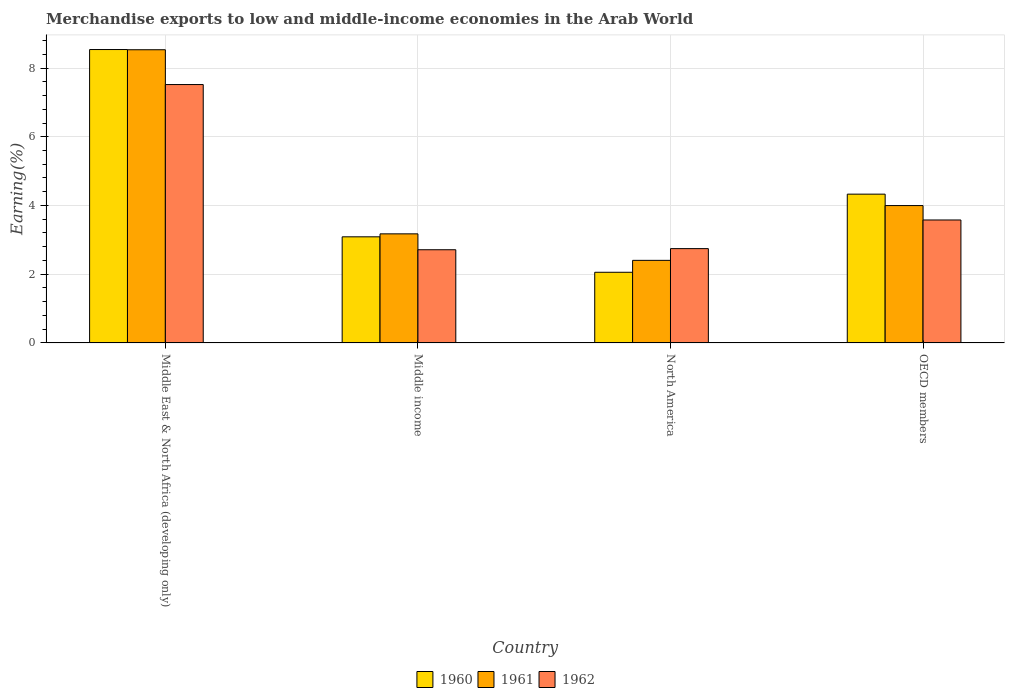How many groups of bars are there?
Provide a succinct answer. 4. Are the number of bars per tick equal to the number of legend labels?
Give a very brief answer. Yes. Are the number of bars on each tick of the X-axis equal?
Offer a very short reply. Yes. How many bars are there on the 1st tick from the left?
Ensure brevity in your answer.  3. In how many cases, is the number of bars for a given country not equal to the number of legend labels?
Ensure brevity in your answer.  0. What is the percentage of amount earned from merchandise exports in 1961 in Middle income?
Provide a succinct answer. 3.17. Across all countries, what is the maximum percentage of amount earned from merchandise exports in 1961?
Your response must be concise. 8.53. Across all countries, what is the minimum percentage of amount earned from merchandise exports in 1962?
Offer a very short reply. 2.71. In which country was the percentage of amount earned from merchandise exports in 1960 maximum?
Offer a terse response. Middle East & North Africa (developing only). In which country was the percentage of amount earned from merchandise exports in 1960 minimum?
Provide a succinct answer. North America. What is the total percentage of amount earned from merchandise exports in 1962 in the graph?
Provide a short and direct response. 16.55. What is the difference between the percentage of amount earned from merchandise exports in 1962 in Middle East & North Africa (developing only) and that in OECD members?
Keep it short and to the point. 3.94. What is the difference between the percentage of amount earned from merchandise exports in 1962 in OECD members and the percentage of amount earned from merchandise exports in 1960 in North America?
Make the answer very short. 1.52. What is the average percentage of amount earned from merchandise exports in 1960 per country?
Your answer should be very brief. 4.5. What is the difference between the percentage of amount earned from merchandise exports of/in 1960 and percentage of amount earned from merchandise exports of/in 1962 in Middle East & North Africa (developing only)?
Keep it short and to the point. 1.02. In how many countries, is the percentage of amount earned from merchandise exports in 1960 greater than 5.2 %?
Your response must be concise. 1. What is the ratio of the percentage of amount earned from merchandise exports in 1960 in Middle East & North Africa (developing only) to that in Middle income?
Keep it short and to the point. 2.76. Is the percentage of amount earned from merchandise exports in 1962 in North America less than that in OECD members?
Your answer should be compact. Yes. What is the difference between the highest and the second highest percentage of amount earned from merchandise exports in 1961?
Give a very brief answer. 4.53. What is the difference between the highest and the lowest percentage of amount earned from merchandise exports in 1961?
Ensure brevity in your answer.  6.13. In how many countries, is the percentage of amount earned from merchandise exports in 1960 greater than the average percentage of amount earned from merchandise exports in 1960 taken over all countries?
Keep it short and to the point. 1. Is the sum of the percentage of amount earned from merchandise exports in 1961 in Middle East & North Africa (developing only) and North America greater than the maximum percentage of amount earned from merchandise exports in 1962 across all countries?
Provide a short and direct response. Yes. How many countries are there in the graph?
Offer a very short reply. 4. Does the graph contain any zero values?
Offer a terse response. No. Does the graph contain grids?
Provide a short and direct response. Yes. Where does the legend appear in the graph?
Provide a succinct answer. Bottom center. What is the title of the graph?
Keep it short and to the point. Merchandise exports to low and middle-income economies in the Arab World. Does "1970" appear as one of the legend labels in the graph?
Provide a succinct answer. No. What is the label or title of the X-axis?
Ensure brevity in your answer.  Country. What is the label or title of the Y-axis?
Give a very brief answer. Earning(%). What is the Earning(%) in 1960 in Middle East & North Africa (developing only)?
Offer a very short reply. 8.54. What is the Earning(%) of 1961 in Middle East & North Africa (developing only)?
Your response must be concise. 8.53. What is the Earning(%) of 1962 in Middle East & North Africa (developing only)?
Your answer should be very brief. 7.52. What is the Earning(%) of 1960 in Middle income?
Give a very brief answer. 3.09. What is the Earning(%) in 1961 in Middle income?
Your answer should be compact. 3.17. What is the Earning(%) in 1962 in Middle income?
Ensure brevity in your answer.  2.71. What is the Earning(%) in 1960 in North America?
Keep it short and to the point. 2.06. What is the Earning(%) in 1961 in North America?
Your answer should be very brief. 2.4. What is the Earning(%) of 1962 in North America?
Ensure brevity in your answer.  2.74. What is the Earning(%) in 1960 in OECD members?
Make the answer very short. 4.33. What is the Earning(%) in 1961 in OECD members?
Your answer should be very brief. 4. What is the Earning(%) of 1962 in OECD members?
Offer a very short reply. 3.58. Across all countries, what is the maximum Earning(%) of 1960?
Give a very brief answer. 8.54. Across all countries, what is the maximum Earning(%) in 1961?
Your response must be concise. 8.53. Across all countries, what is the maximum Earning(%) in 1962?
Make the answer very short. 7.52. Across all countries, what is the minimum Earning(%) in 1960?
Provide a succinct answer. 2.06. Across all countries, what is the minimum Earning(%) in 1961?
Provide a short and direct response. 2.4. Across all countries, what is the minimum Earning(%) of 1962?
Your answer should be compact. 2.71. What is the total Earning(%) of 1960 in the graph?
Provide a short and direct response. 18.01. What is the total Earning(%) in 1961 in the graph?
Ensure brevity in your answer.  18.11. What is the total Earning(%) in 1962 in the graph?
Your answer should be very brief. 16.55. What is the difference between the Earning(%) of 1960 in Middle East & North Africa (developing only) and that in Middle income?
Provide a succinct answer. 5.45. What is the difference between the Earning(%) of 1961 in Middle East & North Africa (developing only) and that in Middle income?
Provide a succinct answer. 5.36. What is the difference between the Earning(%) of 1962 in Middle East & North Africa (developing only) and that in Middle income?
Make the answer very short. 4.81. What is the difference between the Earning(%) in 1960 in Middle East & North Africa (developing only) and that in North America?
Your response must be concise. 6.48. What is the difference between the Earning(%) of 1961 in Middle East & North Africa (developing only) and that in North America?
Your response must be concise. 6.13. What is the difference between the Earning(%) of 1962 in Middle East & North Africa (developing only) and that in North America?
Your answer should be very brief. 4.77. What is the difference between the Earning(%) in 1960 in Middle East & North Africa (developing only) and that in OECD members?
Make the answer very short. 4.21. What is the difference between the Earning(%) of 1961 in Middle East & North Africa (developing only) and that in OECD members?
Offer a very short reply. 4.53. What is the difference between the Earning(%) in 1962 in Middle East & North Africa (developing only) and that in OECD members?
Ensure brevity in your answer.  3.94. What is the difference between the Earning(%) of 1960 in Middle income and that in North America?
Offer a very short reply. 1.03. What is the difference between the Earning(%) of 1961 in Middle income and that in North America?
Offer a terse response. 0.77. What is the difference between the Earning(%) of 1962 in Middle income and that in North America?
Make the answer very short. -0.03. What is the difference between the Earning(%) of 1960 in Middle income and that in OECD members?
Keep it short and to the point. -1.24. What is the difference between the Earning(%) in 1961 in Middle income and that in OECD members?
Your answer should be compact. -0.82. What is the difference between the Earning(%) of 1962 in Middle income and that in OECD members?
Provide a short and direct response. -0.87. What is the difference between the Earning(%) of 1960 in North America and that in OECD members?
Your answer should be compact. -2.27. What is the difference between the Earning(%) in 1961 in North America and that in OECD members?
Your answer should be compact. -1.59. What is the difference between the Earning(%) in 1962 in North America and that in OECD members?
Offer a very short reply. -0.83. What is the difference between the Earning(%) in 1960 in Middle East & North Africa (developing only) and the Earning(%) in 1961 in Middle income?
Offer a very short reply. 5.36. What is the difference between the Earning(%) of 1960 in Middle East & North Africa (developing only) and the Earning(%) of 1962 in Middle income?
Ensure brevity in your answer.  5.83. What is the difference between the Earning(%) of 1961 in Middle East & North Africa (developing only) and the Earning(%) of 1962 in Middle income?
Provide a short and direct response. 5.82. What is the difference between the Earning(%) of 1960 in Middle East & North Africa (developing only) and the Earning(%) of 1961 in North America?
Ensure brevity in your answer.  6.13. What is the difference between the Earning(%) in 1960 in Middle East & North Africa (developing only) and the Earning(%) in 1962 in North America?
Provide a short and direct response. 5.79. What is the difference between the Earning(%) of 1961 in Middle East & North Africa (developing only) and the Earning(%) of 1962 in North America?
Your answer should be very brief. 5.79. What is the difference between the Earning(%) in 1960 in Middle East & North Africa (developing only) and the Earning(%) in 1961 in OECD members?
Offer a very short reply. 4.54. What is the difference between the Earning(%) of 1960 in Middle East & North Africa (developing only) and the Earning(%) of 1962 in OECD members?
Your response must be concise. 4.96. What is the difference between the Earning(%) of 1961 in Middle East & North Africa (developing only) and the Earning(%) of 1962 in OECD members?
Make the answer very short. 4.95. What is the difference between the Earning(%) in 1960 in Middle income and the Earning(%) in 1961 in North America?
Your answer should be compact. 0.68. What is the difference between the Earning(%) in 1960 in Middle income and the Earning(%) in 1962 in North America?
Make the answer very short. 0.34. What is the difference between the Earning(%) of 1961 in Middle income and the Earning(%) of 1962 in North America?
Ensure brevity in your answer.  0.43. What is the difference between the Earning(%) in 1960 in Middle income and the Earning(%) in 1961 in OECD members?
Offer a terse response. -0.91. What is the difference between the Earning(%) of 1960 in Middle income and the Earning(%) of 1962 in OECD members?
Provide a short and direct response. -0.49. What is the difference between the Earning(%) of 1961 in Middle income and the Earning(%) of 1962 in OECD members?
Your response must be concise. -0.4. What is the difference between the Earning(%) of 1960 in North America and the Earning(%) of 1961 in OECD members?
Make the answer very short. -1.94. What is the difference between the Earning(%) of 1960 in North America and the Earning(%) of 1962 in OECD members?
Ensure brevity in your answer.  -1.52. What is the difference between the Earning(%) in 1961 in North America and the Earning(%) in 1962 in OECD members?
Ensure brevity in your answer.  -1.17. What is the average Earning(%) of 1960 per country?
Keep it short and to the point. 4.5. What is the average Earning(%) of 1961 per country?
Provide a succinct answer. 4.53. What is the average Earning(%) in 1962 per country?
Ensure brevity in your answer.  4.14. What is the difference between the Earning(%) of 1960 and Earning(%) of 1961 in Middle East & North Africa (developing only)?
Provide a short and direct response. 0.01. What is the difference between the Earning(%) in 1960 and Earning(%) in 1962 in Middle East & North Africa (developing only)?
Provide a short and direct response. 1.02. What is the difference between the Earning(%) of 1961 and Earning(%) of 1962 in Middle East & North Africa (developing only)?
Make the answer very short. 1.01. What is the difference between the Earning(%) of 1960 and Earning(%) of 1961 in Middle income?
Your response must be concise. -0.09. What is the difference between the Earning(%) in 1960 and Earning(%) in 1962 in Middle income?
Make the answer very short. 0.38. What is the difference between the Earning(%) in 1961 and Earning(%) in 1962 in Middle income?
Give a very brief answer. 0.46. What is the difference between the Earning(%) of 1960 and Earning(%) of 1961 in North America?
Give a very brief answer. -0.35. What is the difference between the Earning(%) of 1960 and Earning(%) of 1962 in North America?
Offer a very short reply. -0.69. What is the difference between the Earning(%) of 1961 and Earning(%) of 1962 in North America?
Offer a very short reply. -0.34. What is the difference between the Earning(%) in 1960 and Earning(%) in 1961 in OECD members?
Your answer should be very brief. 0.33. What is the difference between the Earning(%) of 1960 and Earning(%) of 1962 in OECD members?
Offer a very short reply. 0.75. What is the difference between the Earning(%) in 1961 and Earning(%) in 1962 in OECD members?
Ensure brevity in your answer.  0.42. What is the ratio of the Earning(%) of 1960 in Middle East & North Africa (developing only) to that in Middle income?
Give a very brief answer. 2.76. What is the ratio of the Earning(%) of 1961 in Middle East & North Africa (developing only) to that in Middle income?
Provide a succinct answer. 2.69. What is the ratio of the Earning(%) of 1962 in Middle East & North Africa (developing only) to that in Middle income?
Provide a short and direct response. 2.77. What is the ratio of the Earning(%) in 1960 in Middle East & North Africa (developing only) to that in North America?
Give a very brief answer. 4.15. What is the ratio of the Earning(%) in 1961 in Middle East & North Africa (developing only) to that in North America?
Offer a very short reply. 3.55. What is the ratio of the Earning(%) of 1962 in Middle East & North Africa (developing only) to that in North America?
Your answer should be compact. 2.74. What is the ratio of the Earning(%) in 1960 in Middle East & North Africa (developing only) to that in OECD members?
Offer a terse response. 1.97. What is the ratio of the Earning(%) of 1961 in Middle East & North Africa (developing only) to that in OECD members?
Your answer should be very brief. 2.13. What is the ratio of the Earning(%) in 1962 in Middle East & North Africa (developing only) to that in OECD members?
Your answer should be compact. 2.1. What is the ratio of the Earning(%) of 1960 in Middle income to that in North America?
Offer a very short reply. 1.5. What is the ratio of the Earning(%) of 1961 in Middle income to that in North America?
Offer a terse response. 1.32. What is the ratio of the Earning(%) in 1962 in Middle income to that in North America?
Keep it short and to the point. 0.99. What is the ratio of the Earning(%) of 1960 in Middle income to that in OECD members?
Keep it short and to the point. 0.71. What is the ratio of the Earning(%) in 1961 in Middle income to that in OECD members?
Provide a short and direct response. 0.79. What is the ratio of the Earning(%) of 1962 in Middle income to that in OECD members?
Give a very brief answer. 0.76. What is the ratio of the Earning(%) in 1960 in North America to that in OECD members?
Your answer should be very brief. 0.47. What is the ratio of the Earning(%) of 1961 in North America to that in OECD members?
Your answer should be compact. 0.6. What is the ratio of the Earning(%) of 1962 in North America to that in OECD members?
Your answer should be very brief. 0.77. What is the difference between the highest and the second highest Earning(%) of 1960?
Your answer should be very brief. 4.21. What is the difference between the highest and the second highest Earning(%) in 1961?
Make the answer very short. 4.53. What is the difference between the highest and the second highest Earning(%) of 1962?
Your response must be concise. 3.94. What is the difference between the highest and the lowest Earning(%) in 1960?
Your answer should be compact. 6.48. What is the difference between the highest and the lowest Earning(%) of 1961?
Offer a very short reply. 6.13. What is the difference between the highest and the lowest Earning(%) of 1962?
Keep it short and to the point. 4.81. 